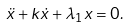Convert formula to latex. <formula><loc_0><loc_0><loc_500><loc_500>\ddot { x } + k \dot { x } + \lambda _ { 1 } x = 0 .</formula> 